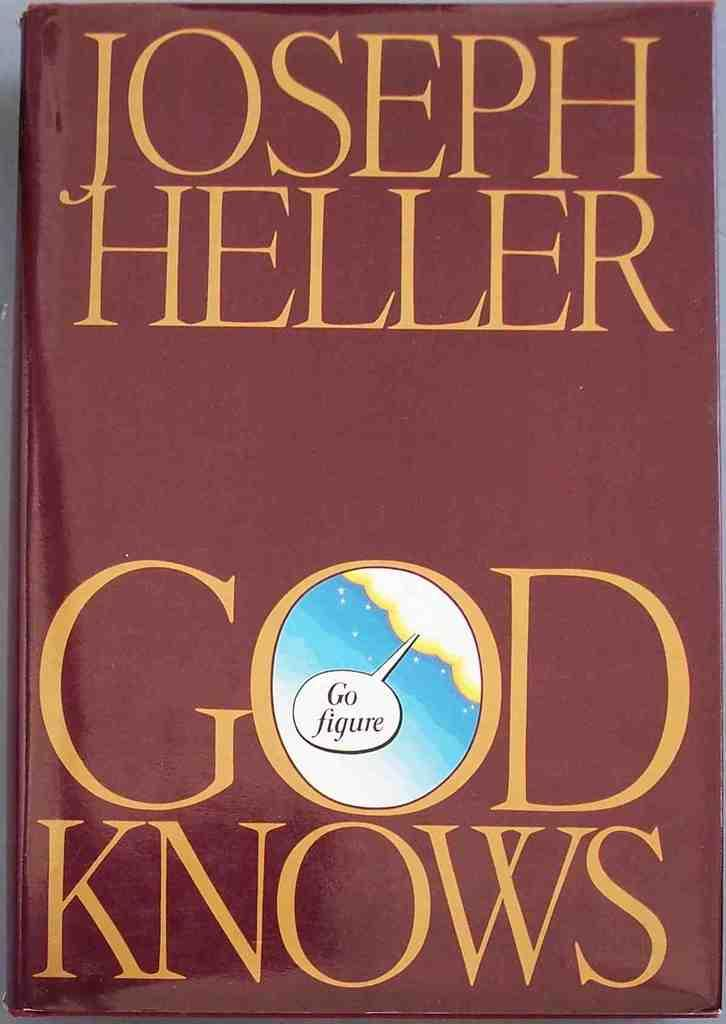Provide a one-sentence caption for the provided image. A burgundy book jacket that is titled God Knows by Joseph Heller. 